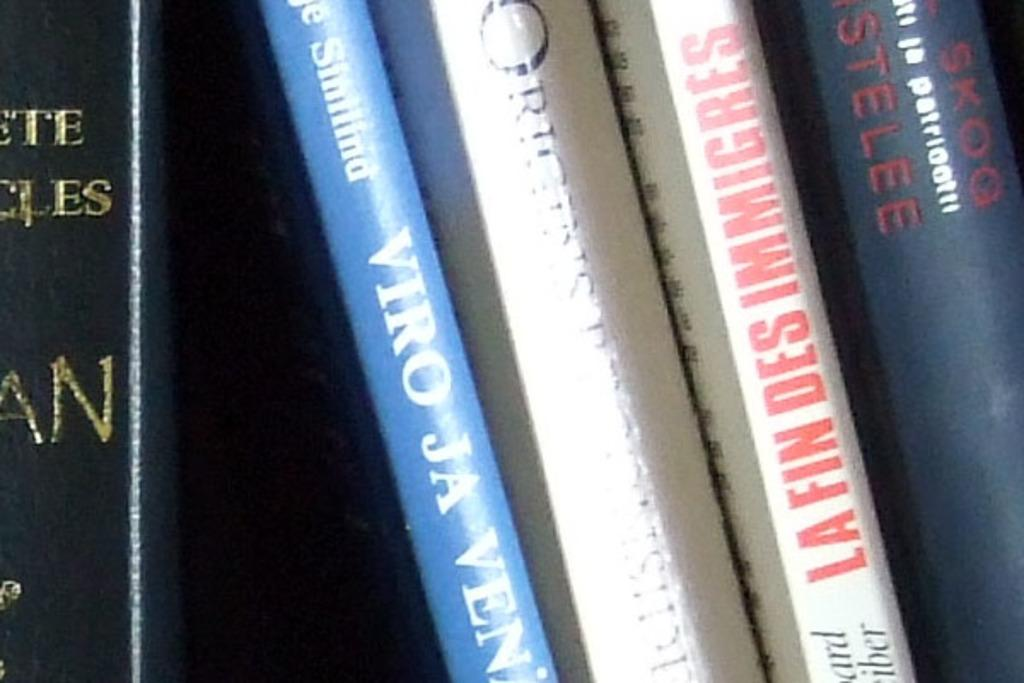<image>
Describe the image concisely. la fin des immigres is one of the books on the shelf 